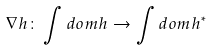<formula> <loc_0><loc_0><loc_500><loc_500>\nabla h \colon \int d o m h \to \int d o m h ^ { * }</formula> 